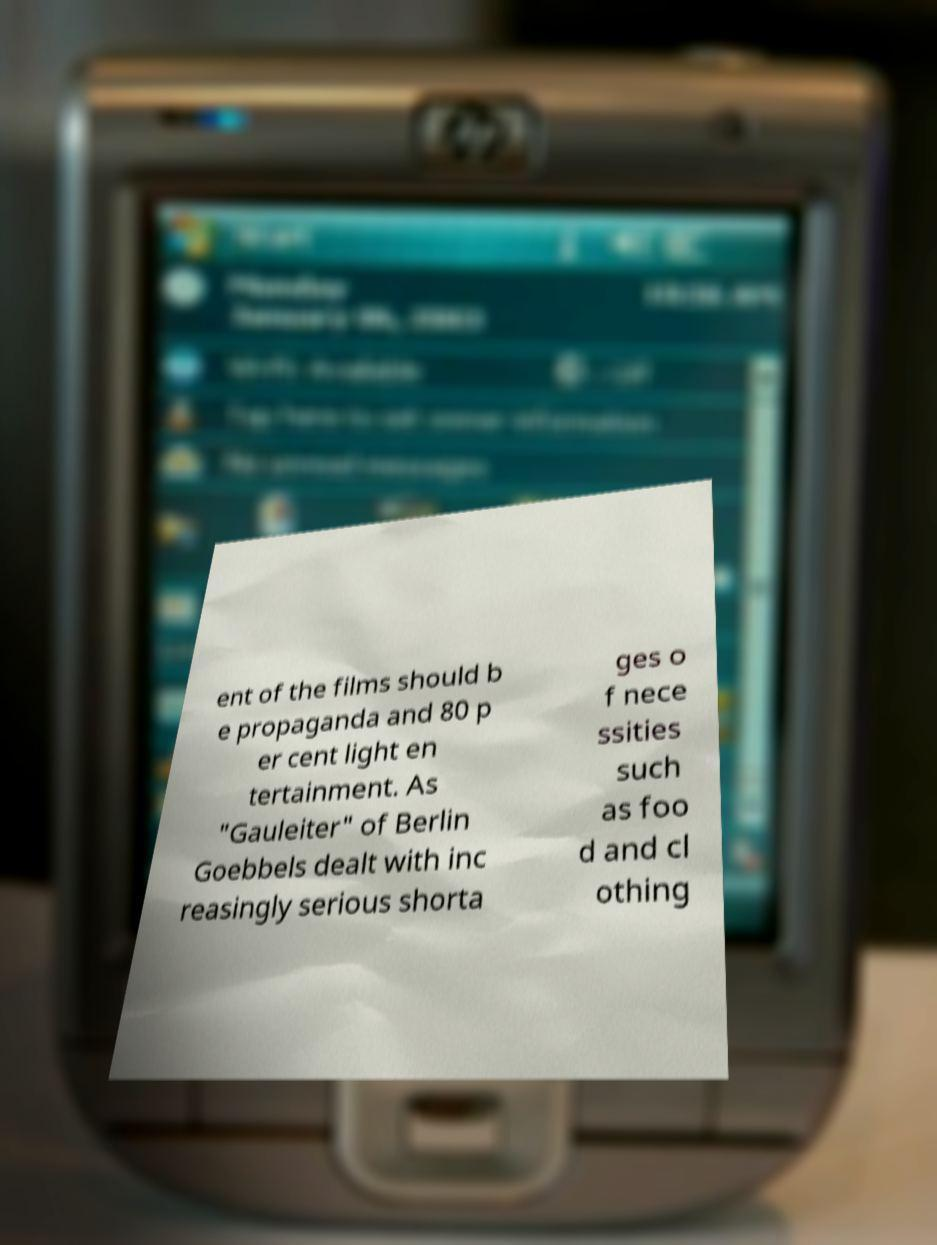Please read and relay the text visible in this image. What does it say? ent of the films should b e propaganda and 80 p er cent light en tertainment. As "Gauleiter" of Berlin Goebbels dealt with inc reasingly serious shorta ges o f nece ssities such as foo d and cl othing 